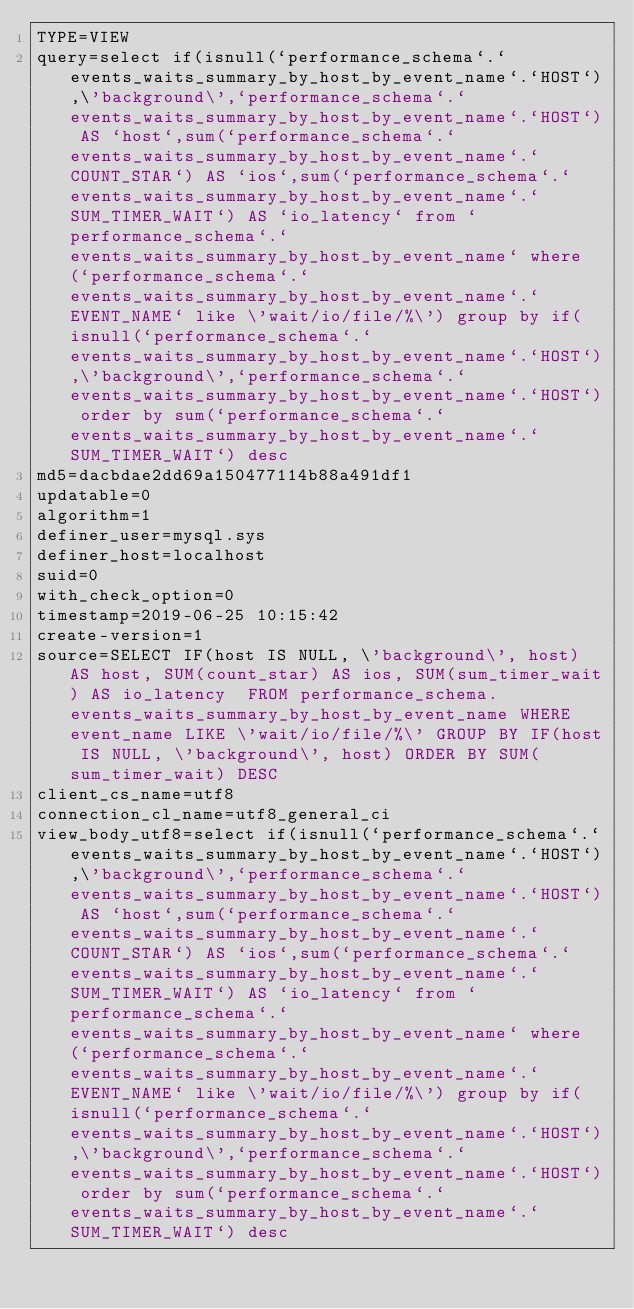Convert code to text. <code><loc_0><loc_0><loc_500><loc_500><_VisualBasic_>TYPE=VIEW
query=select if(isnull(`performance_schema`.`events_waits_summary_by_host_by_event_name`.`HOST`),\'background\',`performance_schema`.`events_waits_summary_by_host_by_event_name`.`HOST`) AS `host`,sum(`performance_schema`.`events_waits_summary_by_host_by_event_name`.`COUNT_STAR`) AS `ios`,sum(`performance_schema`.`events_waits_summary_by_host_by_event_name`.`SUM_TIMER_WAIT`) AS `io_latency` from `performance_schema`.`events_waits_summary_by_host_by_event_name` where (`performance_schema`.`events_waits_summary_by_host_by_event_name`.`EVENT_NAME` like \'wait/io/file/%\') group by if(isnull(`performance_schema`.`events_waits_summary_by_host_by_event_name`.`HOST`),\'background\',`performance_schema`.`events_waits_summary_by_host_by_event_name`.`HOST`) order by sum(`performance_schema`.`events_waits_summary_by_host_by_event_name`.`SUM_TIMER_WAIT`) desc
md5=dacbdae2dd69a150477114b88a491df1
updatable=0
algorithm=1
definer_user=mysql.sys
definer_host=localhost
suid=0
with_check_option=0
timestamp=2019-06-25 10:15:42
create-version=1
source=SELECT IF(host IS NULL, \'background\', host) AS host, SUM(count_star) AS ios, SUM(sum_timer_wait) AS io_latency  FROM performance_schema.events_waits_summary_by_host_by_event_name WHERE event_name LIKE \'wait/io/file/%\' GROUP BY IF(host IS NULL, \'background\', host) ORDER BY SUM(sum_timer_wait) DESC
client_cs_name=utf8
connection_cl_name=utf8_general_ci
view_body_utf8=select if(isnull(`performance_schema`.`events_waits_summary_by_host_by_event_name`.`HOST`),\'background\',`performance_schema`.`events_waits_summary_by_host_by_event_name`.`HOST`) AS `host`,sum(`performance_schema`.`events_waits_summary_by_host_by_event_name`.`COUNT_STAR`) AS `ios`,sum(`performance_schema`.`events_waits_summary_by_host_by_event_name`.`SUM_TIMER_WAIT`) AS `io_latency` from `performance_schema`.`events_waits_summary_by_host_by_event_name` where (`performance_schema`.`events_waits_summary_by_host_by_event_name`.`EVENT_NAME` like \'wait/io/file/%\') group by if(isnull(`performance_schema`.`events_waits_summary_by_host_by_event_name`.`HOST`),\'background\',`performance_schema`.`events_waits_summary_by_host_by_event_name`.`HOST`) order by sum(`performance_schema`.`events_waits_summary_by_host_by_event_name`.`SUM_TIMER_WAIT`) desc
</code> 